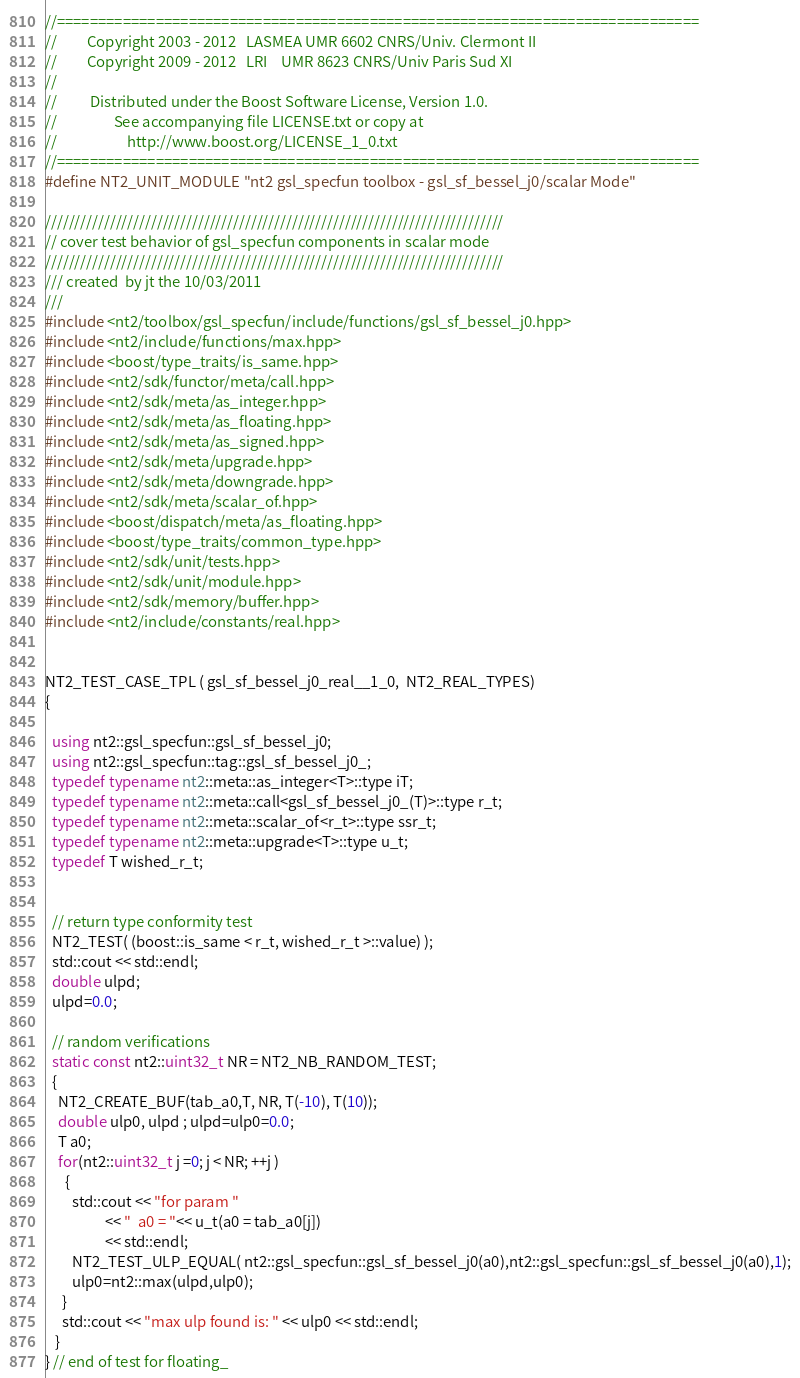Convert code to text. <code><loc_0><loc_0><loc_500><loc_500><_C++_>//==============================================================================
//         Copyright 2003 - 2012   LASMEA UMR 6602 CNRS/Univ. Clermont II
//         Copyright 2009 - 2012   LRI    UMR 8623 CNRS/Univ Paris Sud XI
//
//          Distributed under the Boost Software License, Version 1.0.
//                 See accompanying file LICENSE.txt or copy at
//                     http://www.boost.org/LICENSE_1_0.txt
//==============================================================================
#define NT2_UNIT_MODULE "nt2 gsl_specfun toolbox - gsl_sf_bessel_j0/scalar Mode"

//////////////////////////////////////////////////////////////////////////////
// cover test behavior of gsl_specfun components in scalar mode
//////////////////////////////////////////////////////////////////////////////
/// created  by jt the 10/03/2011
///
#include <nt2/toolbox/gsl_specfun/include/functions/gsl_sf_bessel_j0.hpp>
#include <nt2/include/functions/max.hpp>
#include <boost/type_traits/is_same.hpp>
#include <nt2/sdk/functor/meta/call.hpp>
#include <nt2/sdk/meta/as_integer.hpp>
#include <nt2/sdk/meta/as_floating.hpp>
#include <nt2/sdk/meta/as_signed.hpp>
#include <nt2/sdk/meta/upgrade.hpp>
#include <nt2/sdk/meta/downgrade.hpp>
#include <nt2/sdk/meta/scalar_of.hpp>
#include <boost/dispatch/meta/as_floating.hpp>
#include <boost/type_traits/common_type.hpp>
#include <nt2/sdk/unit/tests.hpp>
#include <nt2/sdk/unit/module.hpp>
#include <nt2/sdk/memory/buffer.hpp>
#include <nt2/include/constants/real.hpp>


NT2_TEST_CASE_TPL ( gsl_sf_bessel_j0_real__1_0,  NT2_REAL_TYPES)
{

  using nt2::gsl_specfun::gsl_sf_bessel_j0;
  using nt2::gsl_specfun::tag::gsl_sf_bessel_j0_;
  typedef typename nt2::meta::as_integer<T>::type iT;
  typedef typename nt2::meta::call<gsl_sf_bessel_j0_(T)>::type r_t;
  typedef typename nt2::meta::scalar_of<r_t>::type ssr_t;
  typedef typename nt2::meta::upgrade<T>::type u_t;
  typedef T wished_r_t;


  // return type conformity test
  NT2_TEST( (boost::is_same < r_t, wished_r_t >::value) );
  std::cout << std::endl;
  double ulpd;
  ulpd=0.0;

  // random verifications
  static const nt2::uint32_t NR = NT2_NB_RANDOM_TEST;
  {
    NT2_CREATE_BUF(tab_a0,T, NR, T(-10), T(10));
    double ulp0, ulpd ; ulpd=ulp0=0.0;
    T a0;
    for(nt2::uint32_t j =0; j < NR; ++j )
      {
        std::cout << "for param "
                  << "  a0 = "<< u_t(a0 = tab_a0[j])
                  << std::endl;
        NT2_TEST_ULP_EQUAL( nt2::gsl_specfun::gsl_sf_bessel_j0(a0),nt2::gsl_specfun::gsl_sf_bessel_j0(a0),1);
        ulp0=nt2::max(ulpd,ulp0);
     }
     std::cout << "max ulp found is: " << ulp0 << std::endl;
   }
} // end of test for floating_
</code> 